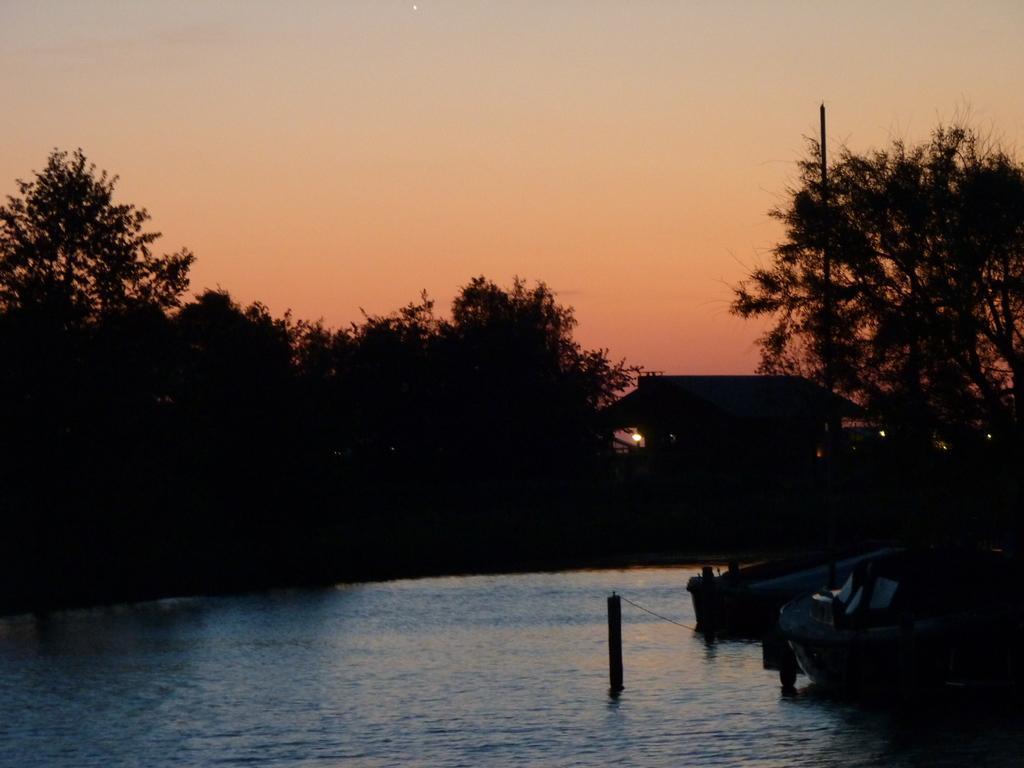Describe this image in one or two sentences. In the image there is a water surface and on the right side there are boats, around the water surface there are a lot of trees. 